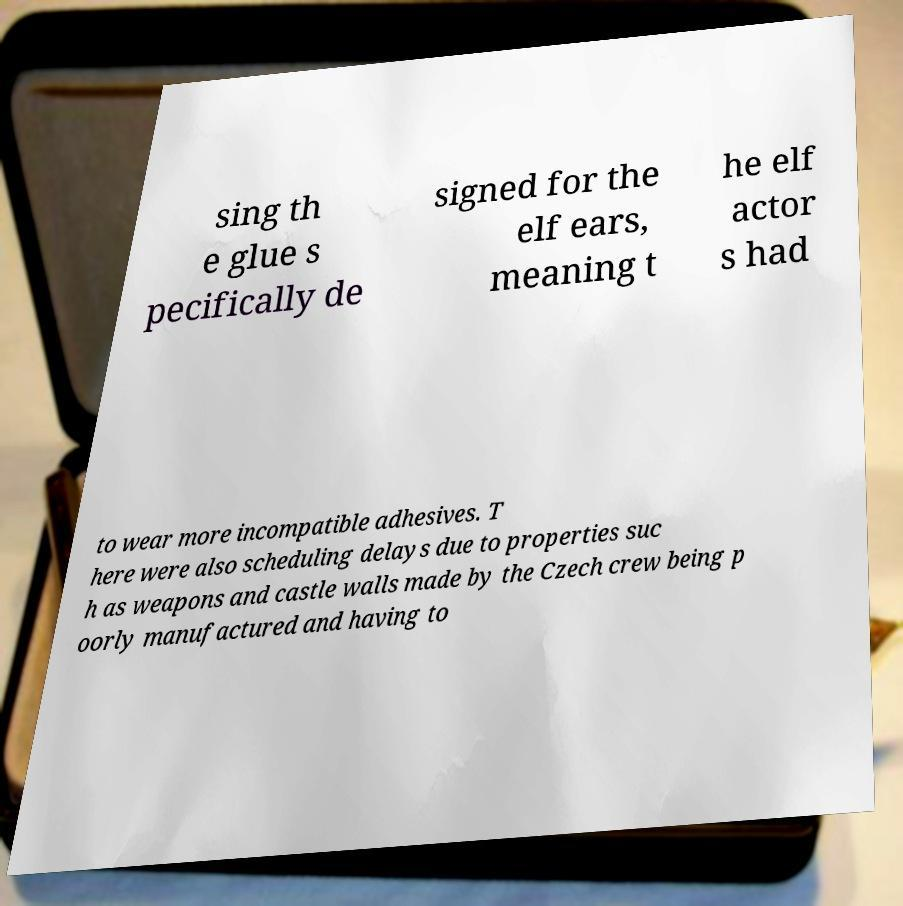Could you assist in decoding the text presented in this image and type it out clearly? sing th e glue s pecifically de signed for the elf ears, meaning t he elf actor s had to wear more incompatible adhesives. T here were also scheduling delays due to properties suc h as weapons and castle walls made by the Czech crew being p oorly manufactured and having to 